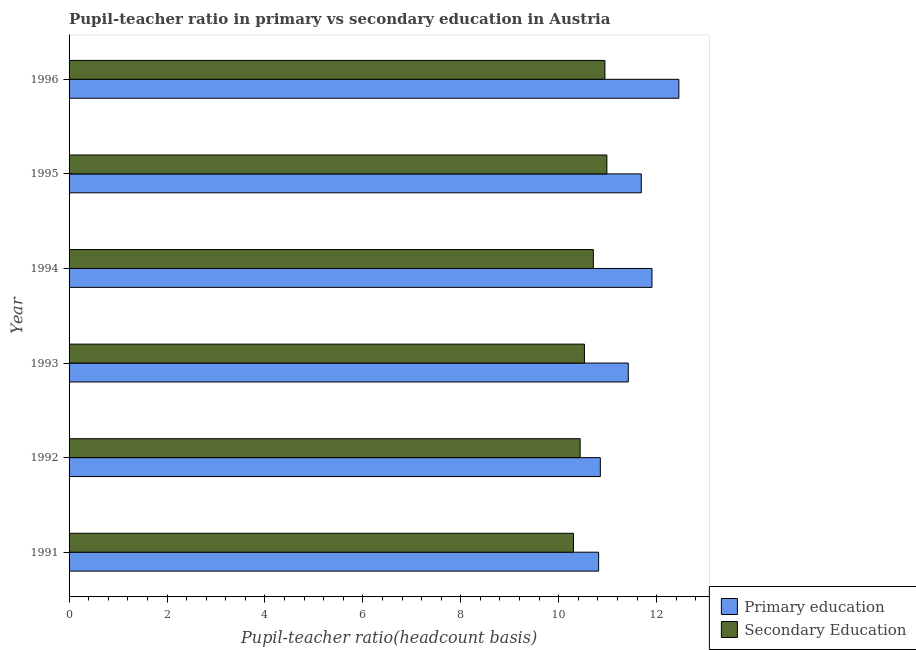How many different coloured bars are there?
Make the answer very short. 2. How many groups of bars are there?
Your answer should be very brief. 6. Are the number of bars per tick equal to the number of legend labels?
Provide a short and direct response. Yes. Are the number of bars on each tick of the Y-axis equal?
Provide a short and direct response. Yes. How many bars are there on the 4th tick from the top?
Ensure brevity in your answer.  2. What is the label of the 4th group of bars from the top?
Provide a succinct answer. 1993. What is the pupil teacher ratio on secondary education in 1996?
Provide a short and direct response. 10.94. Across all years, what is the maximum pupil-teacher ratio in primary education?
Provide a short and direct response. 12.45. Across all years, what is the minimum pupil-teacher ratio in primary education?
Keep it short and to the point. 10.81. In which year was the pupil-teacher ratio in primary education minimum?
Your answer should be compact. 1991. What is the total pupil-teacher ratio in primary education in the graph?
Offer a very short reply. 69.13. What is the difference between the pupil-teacher ratio in primary education in 1995 and that in 1996?
Your response must be concise. -0.77. What is the difference between the pupil-teacher ratio in primary education in 1991 and the pupil teacher ratio on secondary education in 1994?
Offer a very short reply. 0.11. What is the average pupil teacher ratio on secondary education per year?
Your response must be concise. 10.65. In the year 1995, what is the difference between the pupil-teacher ratio in primary education and pupil teacher ratio on secondary education?
Your response must be concise. 0.7. What is the ratio of the pupil-teacher ratio in primary education in 1992 to that in 1996?
Provide a short and direct response. 0.87. Is the pupil-teacher ratio in primary education in 1993 less than that in 1996?
Your response must be concise. Yes. What is the difference between the highest and the second highest pupil-teacher ratio in primary education?
Make the answer very short. 0.55. What is the difference between the highest and the lowest pupil-teacher ratio in primary education?
Make the answer very short. 1.64. In how many years, is the pupil teacher ratio on secondary education greater than the average pupil teacher ratio on secondary education taken over all years?
Your response must be concise. 3. Is the sum of the pupil-teacher ratio in primary education in 1991 and 1994 greater than the maximum pupil teacher ratio on secondary education across all years?
Your answer should be very brief. Yes. What does the 1st bar from the top in 1991 represents?
Offer a very short reply. Secondary Education. What does the 1st bar from the bottom in 1994 represents?
Provide a short and direct response. Primary education. How many years are there in the graph?
Keep it short and to the point. 6. Are the values on the major ticks of X-axis written in scientific E-notation?
Your response must be concise. No. Does the graph contain any zero values?
Keep it short and to the point. No. Where does the legend appear in the graph?
Offer a terse response. Bottom right. How many legend labels are there?
Provide a short and direct response. 2. What is the title of the graph?
Provide a short and direct response. Pupil-teacher ratio in primary vs secondary education in Austria. Does "Chemicals" appear as one of the legend labels in the graph?
Provide a short and direct response. No. What is the label or title of the X-axis?
Provide a short and direct response. Pupil-teacher ratio(headcount basis). What is the label or title of the Y-axis?
Your answer should be very brief. Year. What is the Pupil-teacher ratio(headcount basis) of Primary education in 1991?
Your answer should be very brief. 10.81. What is the Pupil-teacher ratio(headcount basis) of Secondary Education in 1991?
Your answer should be compact. 10.3. What is the Pupil-teacher ratio(headcount basis) in Primary education in 1992?
Give a very brief answer. 10.85. What is the Pupil-teacher ratio(headcount basis) of Secondary Education in 1992?
Make the answer very short. 10.44. What is the Pupil-teacher ratio(headcount basis) in Primary education in 1993?
Your answer should be very brief. 11.42. What is the Pupil-teacher ratio(headcount basis) of Secondary Education in 1993?
Provide a succinct answer. 10.53. What is the Pupil-teacher ratio(headcount basis) of Primary education in 1994?
Give a very brief answer. 11.9. What is the Pupil-teacher ratio(headcount basis) in Secondary Education in 1994?
Ensure brevity in your answer.  10.71. What is the Pupil-teacher ratio(headcount basis) of Primary education in 1995?
Provide a succinct answer. 11.69. What is the Pupil-teacher ratio(headcount basis) in Secondary Education in 1995?
Give a very brief answer. 10.98. What is the Pupil-teacher ratio(headcount basis) in Primary education in 1996?
Ensure brevity in your answer.  12.45. What is the Pupil-teacher ratio(headcount basis) of Secondary Education in 1996?
Your answer should be compact. 10.94. Across all years, what is the maximum Pupil-teacher ratio(headcount basis) of Primary education?
Offer a very short reply. 12.45. Across all years, what is the maximum Pupil-teacher ratio(headcount basis) in Secondary Education?
Make the answer very short. 10.98. Across all years, what is the minimum Pupil-teacher ratio(headcount basis) of Primary education?
Ensure brevity in your answer.  10.81. Across all years, what is the minimum Pupil-teacher ratio(headcount basis) in Secondary Education?
Make the answer very short. 10.3. What is the total Pupil-teacher ratio(headcount basis) in Primary education in the graph?
Your answer should be compact. 69.13. What is the total Pupil-teacher ratio(headcount basis) of Secondary Education in the graph?
Your response must be concise. 63.9. What is the difference between the Pupil-teacher ratio(headcount basis) in Primary education in 1991 and that in 1992?
Keep it short and to the point. -0.04. What is the difference between the Pupil-teacher ratio(headcount basis) in Secondary Education in 1991 and that in 1992?
Give a very brief answer. -0.14. What is the difference between the Pupil-teacher ratio(headcount basis) in Primary education in 1991 and that in 1993?
Make the answer very short. -0.61. What is the difference between the Pupil-teacher ratio(headcount basis) in Secondary Education in 1991 and that in 1993?
Your answer should be very brief. -0.22. What is the difference between the Pupil-teacher ratio(headcount basis) in Primary education in 1991 and that in 1994?
Offer a terse response. -1.09. What is the difference between the Pupil-teacher ratio(headcount basis) in Secondary Education in 1991 and that in 1994?
Make the answer very short. -0.41. What is the difference between the Pupil-teacher ratio(headcount basis) in Primary education in 1991 and that in 1995?
Provide a succinct answer. -0.87. What is the difference between the Pupil-teacher ratio(headcount basis) of Secondary Education in 1991 and that in 1995?
Offer a terse response. -0.68. What is the difference between the Pupil-teacher ratio(headcount basis) in Primary education in 1991 and that in 1996?
Provide a short and direct response. -1.64. What is the difference between the Pupil-teacher ratio(headcount basis) in Secondary Education in 1991 and that in 1996?
Ensure brevity in your answer.  -0.64. What is the difference between the Pupil-teacher ratio(headcount basis) of Primary education in 1992 and that in 1993?
Provide a succinct answer. -0.57. What is the difference between the Pupil-teacher ratio(headcount basis) of Secondary Education in 1992 and that in 1993?
Your response must be concise. -0.09. What is the difference between the Pupil-teacher ratio(headcount basis) of Primary education in 1992 and that in 1994?
Make the answer very short. -1.05. What is the difference between the Pupil-teacher ratio(headcount basis) in Secondary Education in 1992 and that in 1994?
Give a very brief answer. -0.27. What is the difference between the Pupil-teacher ratio(headcount basis) of Primary education in 1992 and that in 1995?
Provide a succinct answer. -0.84. What is the difference between the Pupil-teacher ratio(headcount basis) of Secondary Education in 1992 and that in 1995?
Your answer should be very brief. -0.55. What is the difference between the Pupil-teacher ratio(headcount basis) in Primary education in 1992 and that in 1996?
Offer a very short reply. -1.6. What is the difference between the Pupil-teacher ratio(headcount basis) of Secondary Education in 1992 and that in 1996?
Keep it short and to the point. -0.51. What is the difference between the Pupil-teacher ratio(headcount basis) in Primary education in 1993 and that in 1994?
Your answer should be compact. -0.48. What is the difference between the Pupil-teacher ratio(headcount basis) in Secondary Education in 1993 and that in 1994?
Give a very brief answer. -0.18. What is the difference between the Pupil-teacher ratio(headcount basis) in Primary education in 1993 and that in 1995?
Your response must be concise. -0.27. What is the difference between the Pupil-teacher ratio(headcount basis) in Secondary Education in 1993 and that in 1995?
Your response must be concise. -0.46. What is the difference between the Pupil-teacher ratio(headcount basis) in Primary education in 1993 and that in 1996?
Ensure brevity in your answer.  -1.03. What is the difference between the Pupil-teacher ratio(headcount basis) of Secondary Education in 1993 and that in 1996?
Your answer should be compact. -0.42. What is the difference between the Pupil-teacher ratio(headcount basis) in Primary education in 1994 and that in 1995?
Offer a very short reply. 0.22. What is the difference between the Pupil-teacher ratio(headcount basis) of Secondary Education in 1994 and that in 1995?
Provide a short and direct response. -0.28. What is the difference between the Pupil-teacher ratio(headcount basis) in Primary education in 1994 and that in 1996?
Make the answer very short. -0.55. What is the difference between the Pupil-teacher ratio(headcount basis) of Secondary Education in 1994 and that in 1996?
Give a very brief answer. -0.24. What is the difference between the Pupil-teacher ratio(headcount basis) in Primary education in 1995 and that in 1996?
Offer a very short reply. -0.77. What is the difference between the Pupil-teacher ratio(headcount basis) of Secondary Education in 1995 and that in 1996?
Your answer should be very brief. 0.04. What is the difference between the Pupil-teacher ratio(headcount basis) of Primary education in 1991 and the Pupil-teacher ratio(headcount basis) of Secondary Education in 1992?
Give a very brief answer. 0.38. What is the difference between the Pupil-teacher ratio(headcount basis) of Primary education in 1991 and the Pupil-teacher ratio(headcount basis) of Secondary Education in 1993?
Your response must be concise. 0.29. What is the difference between the Pupil-teacher ratio(headcount basis) in Primary education in 1991 and the Pupil-teacher ratio(headcount basis) in Secondary Education in 1994?
Make the answer very short. 0.11. What is the difference between the Pupil-teacher ratio(headcount basis) of Primary education in 1991 and the Pupil-teacher ratio(headcount basis) of Secondary Education in 1995?
Provide a succinct answer. -0.17. What is the difference between the Pupil-teacher ratio(headcount basis) in Primary education in 1991 and the Pupil-teacher ratio(headcount basis) in Secondary Education in 1996?
Provide a succinct answer. -0.13. What is the difference between the Pupil-teacher ratio(headcount basis) in Primary education in 1992 and the Pupil-teacher ratio(headcount basis) in Secondary Education in 1993?
Provide a succinct answer. 0.32. What is the difference between the Pupil-teacher ratio(headcount basis) in Primary education in 1992 and the Pupil-teacher ratio(headcount basis) in Secondary Education in 1994?
Ensure brevity in your answer.  0.14. What is the difference between the Pupil-teacher ratio(headcount basis) of Primary education in 1992 and the Pupil-teacher ratio(headcount basis) of Secondary Education in 1995?
Your response must be concise. -0.13. What is the difference between the Pupil-teacher ratio(headcount basis) in Primary education in 1992 and the Pupil-teacher ratio(headcount basis) in Secondary Education in 1996?
Make the answer very short. -0.09. What is the difference between the Pupil-teacher ratio(headcount basis) of Primary education in 1993 and the Pupil-teacher ratio(headcount basis) of Secondary Education in 1994?
Your answer should be compact. 0.71. What is the difference between the Pupil-teacher ratio(headcount basis) of Primary education in 1993 and the Pupil-teacher ratio(headcount basis) of Secondary Education in 1995?
Provide a short and direct response. 0.44. What is the difference between the Pupil-teacher ratio(headcount basis) in Primary education in 1993 and the Pupil-teacher ratio(headcount basis) in Secondary Education in 1996?
Offer a terse response. 0.48. What is the difference between the Pupil-teacher ratio(headcount basis) in Primary education in 1994 and the Pupil-teacher ratio(headcount basis) in Secondary Education in 1995?
Offer a terse response. 0.92. What is the difference between the Pupil-teacher ratio(headcount basis) in Primary education in 1994 and the Pupil-teacher ratio(headcount basis) in Secondary Education in 1996?
Ensure brevity in your answer.  0.96. What is the difference between the Pupil-teacher ratio(headcount basis) of Primary education in 1995 and the Pupil-teacher ratio(headcount basis) of Secondary Education in 1996?
Your answer should be very brief. 0.74. What is the average Pupil-teacher ratio(headcount basis) in Primary education per year?
Provide a succinct answer. 11.52. What is the average Pupil-teacher ratio(headcount basis) of Secondary Education per year?
Your answer should be compact. 10.65. In the year 1991, what is the difference between the Pupil-teacher ratio(headcount basis) of Primary education and Pupil-teacher ratio(headcount basis) of Secondary Education?
Your answer should be compact. 0.51. In the year 1992, what is the difference between the Pupil-teacher ratio(headcount basis) of Primary education and Pupil-teacher ratio(headcount basis) of Secondary Education?
Keep it short and to the point. 0.41. In the year 1993, what is the difference between the Pupil-teacher ratio(headcount basis) of Primary education and Pupil-teacher ratio(headcount basis) of Secondary Education?
Ensure brevity in your answer.  0.9. In the year 1994, what is the difference between the Pupil-teacher ratio(headcount basis) of Primary education and Pupil-teacher ratio(headcount basis) of Secondary Education?
Give a very brief answer. 1.2. In the year 1995, what is the difference between the Pupil-teacher ratio(headcount basis) of Primary education and Pupil-teacher ratio(headcount basis) of Secondary Education?
Offer a very short reply. 0.7. In the year 1996, what is the difference between the Pupil-teacher ratio(headcount basis) in Primary education and Pupil-teacher ratio(headcount basis) in Secondary Education?
Your answer should be very brief. 1.51. What is the ratio of the Pupil-teacher ratio(headcount basis) in Primary education in 1991 to that in 1992?
Keep it short and to the point. 1. What is the ratio of the Pupil-teacher ratio(headcount basis) of Secondary Education in 1991 to that in 1992?
Your answer should be compact. 0.99. What is the ratio of the Pupil-teacher ratio(headcount basis) in Primary education in 1991 to that in 1993?
Your response must be concise. 0.95. What is the ratio of the Pupil-teacher ratio(headcount basis) in Secondary Education in 1991 to that in 1993?
Offer a terse response. 0.98. What is the ratio of the Pupil-teacher ratio(headcount basis) of Primary education in 1991 to that in 1994?
Your answer should be very brief. 0.91. What is the ratio of the Pupil-teacher ratio(headcount basis) of Secondary Education in 1991 to that in 1994?
Offer a very short reply. 0.96. What is the ratio of the Pupil-teacher ratio(headcount basis) in Primary education in 1991 to that in 1995?
Keep it short and to the point. 0.93. What is the ratio of the Pupil-teacher ratio(headcount basis) of Secondary Education in 1991 to that in 1995?
Your answer should be very brief. 0.94. What is the ratio of the Pupil-teacher ratio(headcount basis) in Primary education in 1991 to that in 1996?
Keep it short and to the point. 0.87. What is the ratio of the Pupil-teacher ratio(headcount basis) in Secondary Education in 1991 to that in 1996?
Your answer should be very brief. 0.94. What is the ratio of the Pupil-teacher ratio(headcount basis) of Primary education in 1992 to that in 1993?
Make the answer very short. 0.95. What is the ratio of the Pupil-teacher ratio(headcount basis) in Primary education in 1992 to that in 1994?
Your answer should be compact. 0.91. What is the ratio of the Pupil-teacher ratio(headcount basis) of Secondary Education in 1992 to that in 1994?
Your answer should be very brief. 0.97. What is the ratio of the Pupil-teacher ratio(headcount basis) in Primary education in 1992 to that in 1995?
Ensure brevity in your answer.  0.93. What is the ratio of the Pupil-teacher ratio(headcount basis) in Secondary Education in 1992 to that in 1995?
Ensure brevity in your answer.  0.95. What is the ratio of the Pupil-teacher ratio(headcount basis) of Primary education in 1992 to that in 1996?
Give a very brief answer. 0.87. What is the ratio of the Pupil-teacher ratio(headcount basis) of Secondary Education in 1992 to that in 1996?
Provide a short and direct response. 0.95. What is the ratio of the Pupil-teacher ratio(headcount basis) of Primary education in 1993 to that in 1994?
Offer a very short reply. 0.96. What is the ratio of the Pupil-teacher ratio(headcount basis) of Primary education in 1993 to that in 1995?
Make the answer very short. 0.98. What is the ratio of the Pupil-teacher ratio(headcount basis) of Primary education in 1993 to that in 1996?
Your response must be concise. 0.92. What is the ratio of the Pupil-teacher ratio(headcount basis) of Secondary Education in 1993 to that in 1996?
Give a very brief answer. 0.96. What is the ratio of the Pupil-teacher ratio(headcount basis) in Primary education in 1994 to that in 1995?
Give a very brief answer. 1.02. What is the ratio of the Pupil-teacher ratio(headcount basis) of Secondary Education in 1994 to that in 1995?
Your response must be concise. 0.97. What is the ratio of the Pupil-teacher ratio(headcount basis) in Primary education in 1994 to that in 1996?
Offer a terse response. 0.96. What is the ratio of the Pupil-teacher ratio(headcount basis) of Secondary Education in 1994 to that in 1996?
Provide a short and direct response. 0.98. What is the ratio of the Pupil-teacher ratio(headcount basis) in Primary education in 1995 to that in 1996?
Your answer should be compact. 0.94. What is the ratio of the Pupil-teacher ratio(headcount basis) of Secondary Education in 1995 to that in 1996?
Provide a short and direct response. 1. What is the difference between the highest and the second highest Pupil-teacher ratio(headcount basis) in Primary education?
Your response must be concise. 0.55. What is the difference between the highest and the second highest Pupil-teacher ratio(headcount basis) of Secondary Education?
Your answer should be compact. 0.04. What is the difference between the highest and the lowest Pupil-teacher ratio(headcount basis) in Primary education?
Your response must be concise. 1.64. What is the difference between the highest and the lowest Pupil-teacher ratio(headcount basis) in Secondary Education?
Provide a succinct answer. 0.68. 